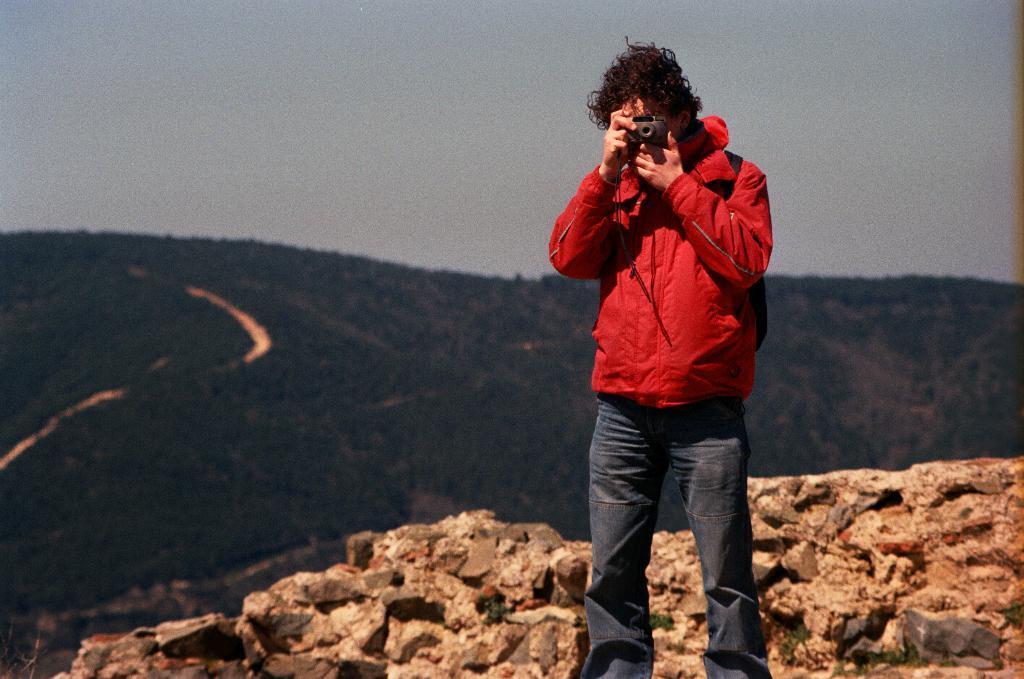Could you give a brief overview of what you see in this image? In the image there is a person standing and holding a camera, it looks like he is capturing something, behind the man in the background there are mountains. 